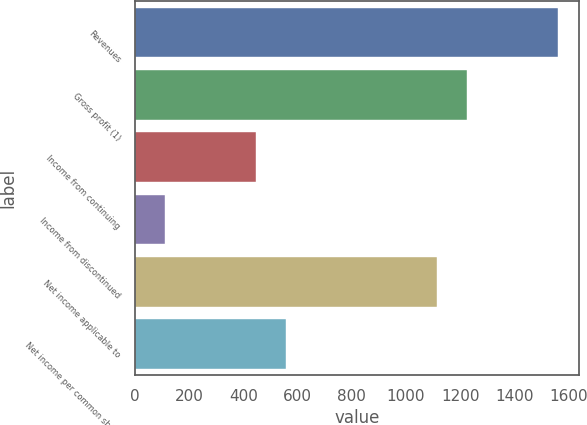<chart> <loc_0><loc_0><loc_500><loc_500><bar_chart><fcel>Revenues<fcel>Gross profit (1)<fcel>Income from continuing<fcel>Income from discontinued<fcel>Net income applicable to<fcel>Net income per common share<nl><fcel>1559.62<fcel>1225.42<fcel>445.62<fcel>111.42<fcel>1114.02<fcel>557.02<nl></chart> 